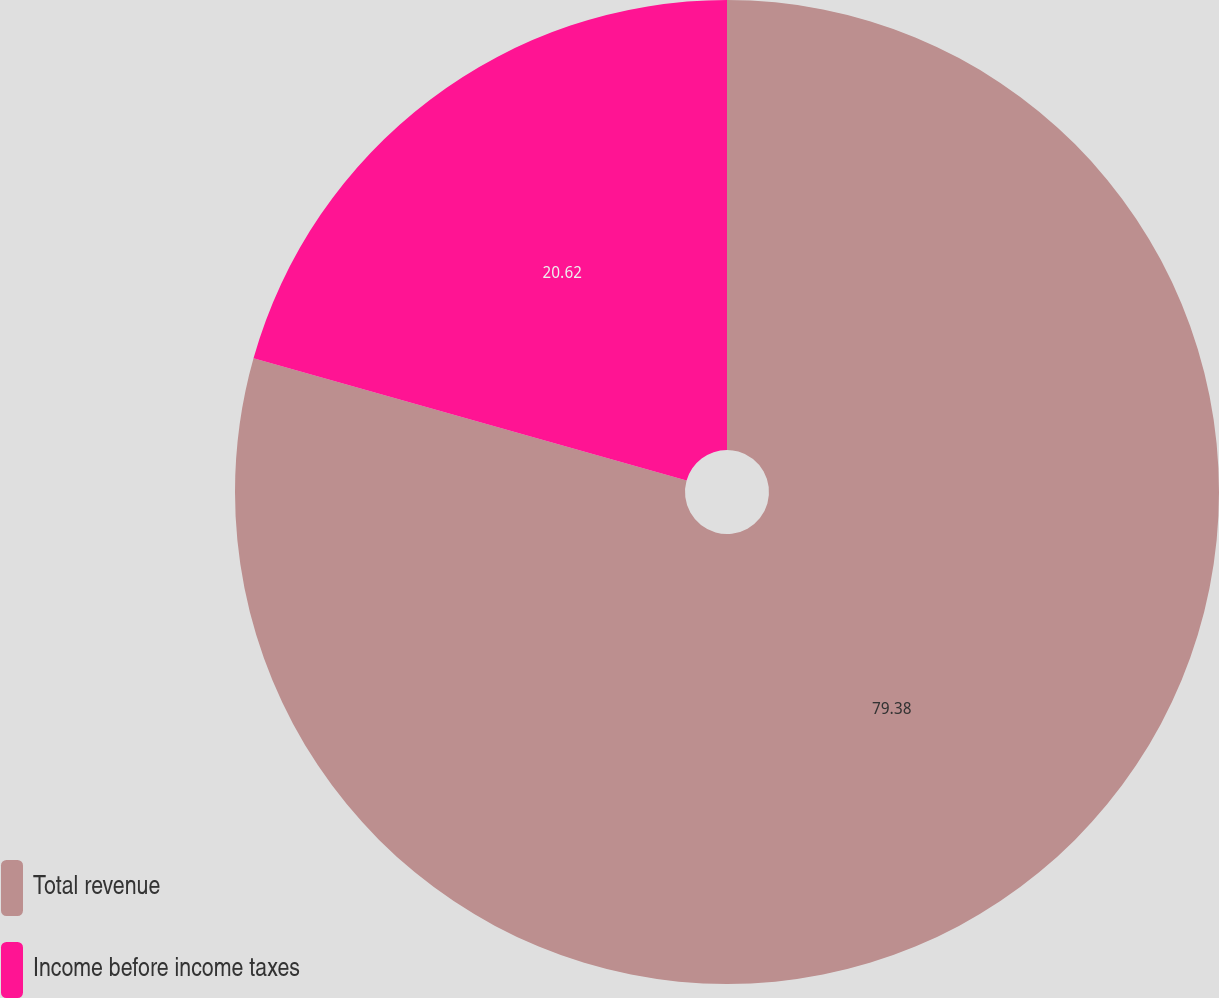<chart> <loc_0><loc_0><loc_500><loc_500><pie_chart><fcel>Total revenue<fcel>Income before income taxes<nl><fcel>79.38%<fcel>20.62%<nl></chart> 